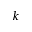Convert formula to latex. <formula><loc_0><loc_0><loc_500><loc_500>k</formula> 